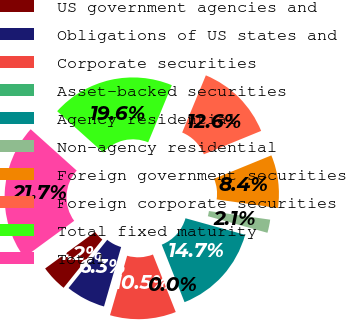<chart> <loc_0><loc_0><loc_500><loc_500><pie_chart><fcel>US government agencies and<fcel>Obligations of US states and<fcel>Corporate securities<fcel>Asset-backed securities<fcel>Agency residential<fcel>Non-agency residential<fcel>Foreign government securities<fcel>Foreign corporate securities<fcel>Total fixed maturity<fcel>Total<nl><fcel>4.19%<fcel>6.29%<fcel>10.48%<fcel>0.0%<fcel>14.67%<fcel>2.1%<fcel>8.39%<fcel>12.58%<fcel>19.6%<fcel>21.7%<nl></chart> 